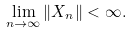<formula> <loc_0><loc_0><loc_500><loc_500>\lim _ { n \rightarrow \infty } \| X _ { n } \| < \infty .</formula> 